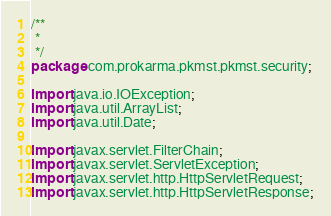<code> <loc_0><loc_0><loc_500><loc_500><_Java_>/**
 * 
 */
package com.prokarma.pkmst.pkmst.security;

import java.io.IOException;
import java.util.ArrayList;
import java.util.Date;

import javax.servlet.FilterChain;
import javax.servlet.ServletException;
import javax.servlet.http.HttpServletRequest;
import javax.servlet.http.HttpServletResponse;
</code> 